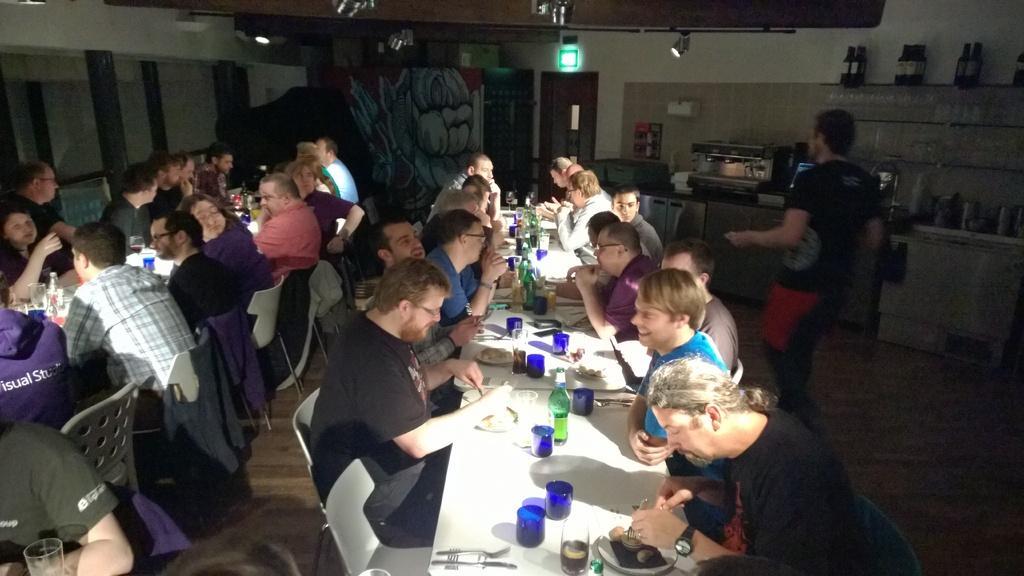Describe this image in one or two sentences. There are many people sitting on chairs. There are tables. on the table there are glasses, bottles , plates and food items. One person wearing a black dress is walking. In the background there is a table and wall. Many bottles are kept there. There is a light and door in the wall. There is a painting in the background. 